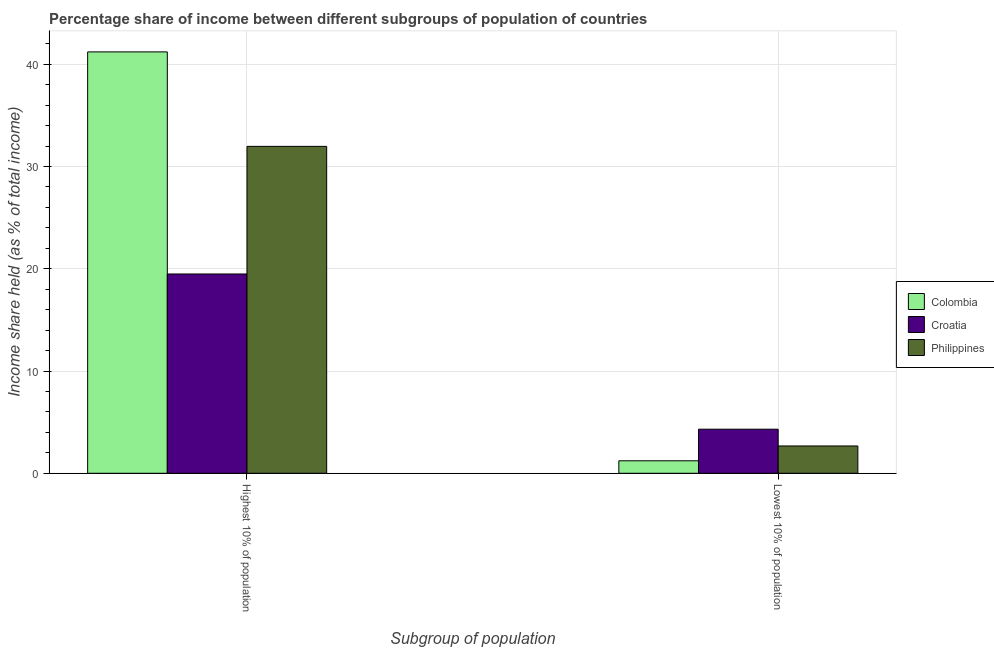How many bars are there on the 2nd tick from the left?
Make the answer very short. 3. How many bars are there on the 1st tick from the right?
Provide a short and direct response. 3. What is the label of the 1st group of bars from the left?
Provide a succinct answer. Highest 10% of population. What is the income share held by lowest 10% of the population in Colombia?
Your answer should be compact. 1.22. Across all countries, what is the maximum income share held by lowest 10% of the population?
Your response must be concise. 4.31. Across all countries, what is the minimum income share held by lowest 10% of the population?
Provide a short and direct response. 1.22. In which country was the income share held by lowest 10% of the population minimum?
Offer a terse response. Colombia. What is the total income share held by lowest 10% of the population in the graph?
Your answer should be very brief. 8.2. What is the difference between the income share held by lowest 10% of the population in Croatia and that in Colombia?
Offer a very short reply. 3.09. What is the difference between the income share held by highest 10% of the population in Croatia and the income share held by lowest 10% of the population in Colombia?
Provide a succinct answer. 18.27. What is the average income share held by highest 10% of the population per country?
Your answer should be compact. 30.89. What is the difference between the income share held by lowest 10% of the population and income share held by highest 10% of the population in Croatia?
Provide a short and direct response. -15.18. What is the ratio of the income share held by lowest 10% of the population in Croatia to that in Philippines?
Ensure brevity in your answer.  1.61. In how many countries, is the income share held by highest 10% of the population greater than the average income share held by highest 10% of the population taken over all countries?
Provide a succinct answer. 2. What does the 2nd bar from the right in Lowest 10% of population represents?
Offer a terse response. Croatia. Are the values on the major ticks of Y-axis written in scientific E-notation?
Give a very brief answer. No. Does the graph contain any zero values?
Your answer should be very brief. No. How are the legend labels stacked?
Make the answer very short. Vertical. What is the title of the graph?
Make the answer very short. Percentage share of income between different subgroups of population of countries. Does "Aruba" appear as one of the legend labels in the graph?
Your answer should be compact. No. What is the label or title of the X-axis?
Offer a very short reply. Subgroup of population. What is the label or title of the Y-axis?
Give a very brief answer. Income share held (as % of total income). What is the Income share held (as % of total income) of Colombia in Highest 10% of population?
Your answer should be very brief. 41.21. What is the Income share held (as % of total income) in Croatia in Highest 10% of population?
Your response must be concise. 19.49. What is the Income share held (as % of total income) of Philippines in Highest 10% of population?
Keep it short and to the point. 31.97. What is the Income share held (as % of total income) of Colombia in Lowest 10% of population?
Your answer should be very brief. 1.22. What is the Income share held (as % of total income) of Croatia in Lowest 10% of population?
Give a very brief answer. 4.31. What is the Income share held (as % of total income) in Philippines in Lowest 10% of population?
Provide a short and direct response. 2.67. Across all Subgroup of population, what is the maximum Income share held (as % of total income) of Colombia?
Your answer should be very brief. 41.21. Across all Subgroup of population, what is the maximum Income share held (as % of total income) in Croatia?
Your response must be concise. 19.49. Across all Subgroup of population, what is the maximum Income share held (as % of total income) in Philippines?
Make the answer very short. 31.97. Across all Subgroup of population, what is the minimum Income share held (as % of total income) in Colombia?
Offer a very short reply. 1.22. Across all Subgroup of population, what is the minimum Income share held (as % of total income) in Croatia?
Provide a short and direct response. 4.31. Across all Subgroup of population, what is the minimum Income share held (as % of total income) in Philippines?
Give a very brief answer. 2.67. What is the total Income share held (as % of total income) of Colombia in the graph?
Ensure brevity in your answer.  42.43. What is the total Income share held (as % of total income) in Croatia in the graph?
Provide a succinct answer. 23.8. What is the total Income share held (as % of total income) in Philippines in the graph?
Provide a short and direct response. 34.64. What is the difference between the Income share held (as % of total income) in Colombia in Highest 10% of population and that in Lowest 10% of population?
Offer a terse response. 39.99. What is the difference between the Income share held (as % of total income) in Croatia in Highest 10% of population and that in Lowest 10% of population?
Make the answer very short. 15.18. What is the difference between the Income share held (as % of total income) of Philippines in Highest 10% of population and that in Lowest 10% of population?
Offer a very short reply. 29.3. What is the difference between the Income share held (as % of total income) of Colombia in Highest 10% of population and the Income share held (as % of total income) of Croatia in Lowest 10% of population?
Ensure brevity in your answer.  36.9. What is the difference between the Income share held (as % of total income) of Colombia in Highest 10% of population and the Income share held (as % of total income) of Philippines in Lowest 10% of population?
Your answer should be compact. 38.54. What is the difference between the Income share held (as % of total income) of Croatia in Highest 10% of population and the Income share held (as % of total income) of Philippines in Lowest 10% of population?
Your response must be concise. 16.82. What is the average Income share held (as % of total income) of Colombia per Subgroup of population?
Make the answer very short. 21.21. What is the average Income share held (as % of total income) of Philippines per Subgroup of population?
Provide a succinct answer. 17.32. What is the difference between the Income share held (as % of total income) of Colombia and Income share held (as % of total income) of Croatia in Highest 10% of population?
Ensure brevity in your answer.  21.72. What is the difference between the Income share held (as % of total income) in Colombia and Income share held (as % of total income) in Philippines in Highest 10% of population?
Ensure brevity in your answer.  9.24. What is the difference between the Income share held (as % of total income) of Croatia and Income share held (as % of total income) of Philippines in Highest 10% of population?
Your response must be concise. -12.48. What is the difference between the Income share held (as % of total income) in Colombia and Income share held (as % of total income) in Croatia in Lowest 10% of population?
Provide a short and direct response. -3.09. What is the difference between the Income share held (as % of total income) of Colombia and Income share held (as % of total income) of Philippines in Lowest 10% of population?
Your answer should be very brief. -1.45. What is the difference between the Income share held (as % of total income) in Croatia and Income share held (as % of total income) in Philippines in Lowest 10% of population?
Your response must be concise. 1.64. What is the ratio of the Income share held (as % of total income) of Colombia in Highest 10% of population to that in Lowest 10% of population?
Offer a very short reply. 33.78. What is the ratio of the Income share held (as % of total income) of Croatia in Highest 10% of population to that in Lowest 10% of population?
Provide a short and direct response. 4.52. What is the ratio of the Income share held (as % of total income) in Philippines in Highest 10% of population to that in Lowest 10% of population?
Make the answer very short. 11.97. What is the difference between the highest and the second highest Income share held (as % of total income) in Colombia?
Make the answer very short. 39.99. What is the difference between the highest and the second highest Income share held (as % of total income) of Croatia?
Provide a short and direct response. 15.18. What is the difference between the highest and the second highest Income share held (as % of total income) of Philippines?
Ensure brevity in your answer.  29.3. What is the difference between the highest and the lowest Income share held (as % of total income) in Colombia?
Make the answer very short. 39.99. What is the difference between the highest and the lowest Income share held (as % of total income) of Croatia?
Make the answer very short. 15.18. What is the difference between the highest and the lowest Income share held (as % of total income) of Philippines?
Your answer should be very brief. 29.3. 